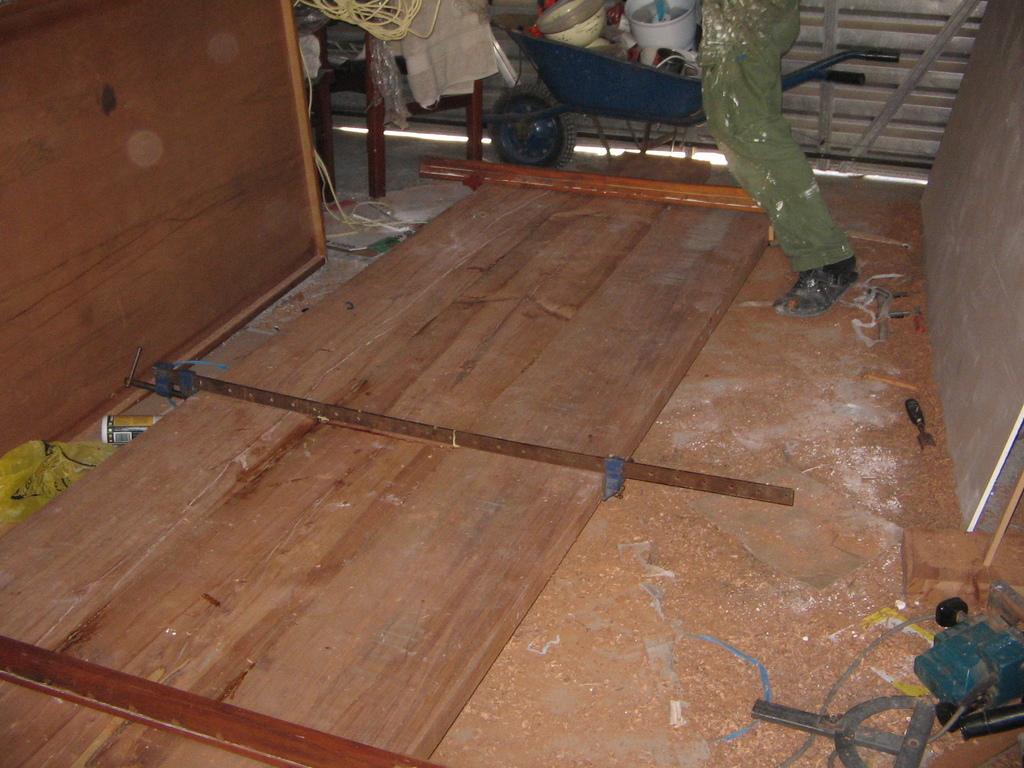Please provide a concise description of this image. In this picture I can see the person's leg who is wearing trouser and shoe. He is standing near to wooden door which is kept on the floor. Beside that I can see some wooden sheets. At the top I can see the buckets, rice cooker and other objects on the trolley. Beside that I can see the shelter. On the top left corner I can see the wooden sheet, beside that there is a chair. On the left I can see the bottle and cloth. 